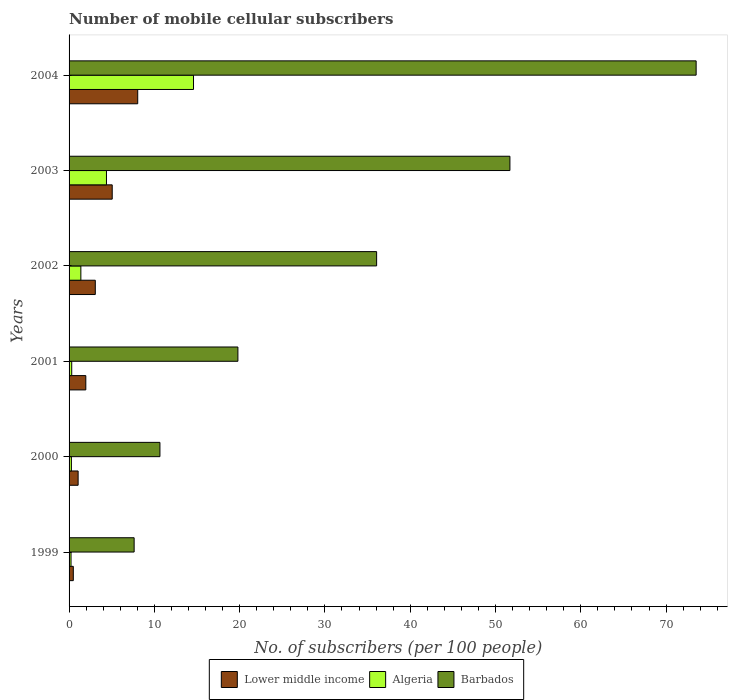How many different coloured bars are there?
Make the answer very short. 3. Are the number of bars on each tick of the Y-axis equal?
Ensure brevity in your answer.  Yes. What is the label of the 1st group of bars from the top?
Make the answer very short. 2004. In how many cases, is the number of bars for a given year not equal to the number of legend labels?
Offer a very short reply. 0. What is the number of mobile cellular subscribers in Algeria in 2000?
Make the answer very short. 0.27. Across all years, what is the maximum number of mobile cellular subscribers in Barbados?
Your answer should be very brief. 73.52. Across all years, what is the minimum number of mobile cellular subscribers in Lower middle income?
Your answer should be very brief. 0.5. In which year was the number of mobile cellular subscribers in Barbados maximum?
Provide a succinct answer. 2004. In which year was the number of mobile cellular subscribers in Lower middle income minimum?
Make the answer very short. 1999. What is the total number of mobile cellular subscribers in Barbados in the graph?
Your answer should be compact. 199.35. What is the difference between the number of mobile cellular subscribers in Barbados in 2001 and that in 2004?
Offer a very short reply. -53.73. What is the difference between the number of mobile cellular subscribers in Barbados in 2003 and the number of mobile cellular subscribers in Lower middle income in 2002?
Provide a succinct answer. 48.62. What is the average number of mobile cellular subscribers in Lower middle income per year?
Offer a very short reply. 3.28. In the year 2002, what is the difference between the number of mobile cellular subscribers in Algeria and number of mobile cellular subscribers in Barbados?
Ensure brevity in your answer.  -34.68. In how many years, is the number of mobile cellular subscribers in Lower middle income greater than 30 ?
Ensure brevity in your answer.  0. What is the ratio of the number of mobile cellular subscribers in Barbados in 2000 to that in 2001?
Your answer should be very brief. 0.54. Is the number of mobile cellular subscribers in Algeria in 2000 less than that in 2001?
Your response must be concise. Yes. What is the difference between the highest and the second highest number of mobile cellular subscribers in Lower middle income?
Your answer should be very brief. 2.99. What is the difference between the highest and the lowest number of mobile cellular subscribers in Algeria?
Keep it short and to the point. 14.36. In how many years, is the number of mobile cellular subscribers in Barbados greater than the average number of mobile cellular subscribers in Barbados taken over all years?
Your answer should be very brief. 3. What does the 2nd bar from the top in 2002 represents?
Give a very brief answer. Algeria. What does the 2nd bar from the bottom in 2000 represents?
Your answer should be compact. Algeria. Are the values on the major ticks of X-axis written in scientific E-notation?
Give a very brief answer. No. Does the graph contain any zero values?
Your response must be concise. No. How many legend labels are there?
Give a very brief answer. 3. How are the legend labels stacked?
Make the answer very short. Horizontal. What is the title of the graph?
Your response must be concise. Number of mobile cellular subscribers. Does "Faeroe Islands" appear as one of the legend labels in the graph?
Your answer should be very brief. No. What is the label or title of the X-axis?
Keep it short and to the point. No. of subscribers (per 100 people). What is the label or title of the Y-axis?
Your answer should be compact. Years. What is the No. of subscribers (per 100 people) of Lower middle income in 1999?
Ensure brevity in your answer.  0.5. What is the No. of subscribers (per 100 people) of Algeria in 1999?
Ensure brevity in your answer.  0.23. What is the No. of subscribers (per 100 people) in Barbados in 1999?
Ensure brevity in your answer.  7.63. What is the No. of subscribers (per 100 people) of Lower middle income in 2000?
Your answer should be compact. 1.06. What is the No. of subscribers (per 100 people) of Algeria in 2000?
Your answer should be very brief. 0.27. What is the No. of subscribers (per 100 people) in Barbados in 2000?
Offer a terse response. 10.65. What is the No. of subscribers (per 100 people) in Lower middle income in 2001?
Your answer should be very brief. 1.96. What is the No. of subscribers (per 100 people) of Algeria in 2001?
Your answer should be very brief. 0.31. What is the No. of subscribers (per 100 people) in Barbados in 2001?
Your response must be concise. 19.8. What is the No. of subscribers (per 100 people) in Lower middle income in 2002?
Keep it short and to the point. 3.07. What is the No. of subscribers (per 100 people) of Algeria in 2002?
Provide a short and direct response. 1.38. What is the No. of subscribers (per 100 people) of Barbados in 2002?
Your answer should be compact. 36.06. What is the No. of subscribers (per 100 people) in Lower middle income in 2003?
Ensure brevity in your answer.  5.06. What is the No. of subscribers (per 100 people) of Algeria in 2003?
Provide a succinct answer. 4.38. What is the No. of subscribers (per 100 people) of Barbados in 2003?
Offer a terse response. 51.69. What is the No. of subscribers (per 100 people) in Lower middle income in 2004?
Offer a terse response. 8.05. What is the No. of subscribers (per 100 people) in Algeria in 2004?
Offer a very short reply. 14.59. What is the No. of subscribers (per 100 people) in Barbados in 2004?
Give a very brief answer. 73.52. Across all years, what is the maximum No. of subscribers (per 100 people) of Lower middle income?
Provide a succinct answer. 8.05. Across all years, what is the maximum No. of subscribers (per 100 people) in Algeria?
Give a very brief answer. 14.59. Across all years, what is the maximum No. of subscribers (per 100 people) of Barbados?
Make the answer very short. 73.52. Across all years, what is the minimum No. of subscribers (per 100 people) in Lower middle income?
Keep it short and to the point. 0.5. Across all years, what is the minimum No. of subscribers (per 100 people) in Algeria?
Your response must be concise. 0.23. Across all years, what is the minimum No. of subscribers (per 100 people) in Barbados?
Ensure brevity in your answer.  7.63. What is the total No. of subscribers (per 100 people) of Lower middle income in the graph?
Keep it short and to the point. 19.7. What is the total No. of subscribers (per 100 people) in Algeria in the graph?
Keep it short and to the point. 21.17. What is the total No. of subscribers (per 100 people) in Barbados in the graph?
Offer a very short reply. 199.35. What is the difference between the No. of subscribers (per 100 people) in Lower middle income in 1999 and that in 2000?
Ensure brevity in your answer.  -0.56. What is the difference between the No. of subscribers (per 100 people) in Algeria in 1999 and that in 2000?
Provide a short and direct response. -0.04. What is the difference between the No. of subscribers (per 100 people) in Barbados in 1999 and that in 2000?
Your response must be concise. -3.03. What is the difference between the No. of subscribers (per 100 people) in Lower middle income in 1999 and that in 2001?
Provide a short and direct response. -1.47. What is the difference between the No. of subscribers (per 100 people) in Algeria in 1999 and that in 2001?
Offer a very short reply. -0.08. What is the difference between the No. of subscribers (per 100 people) of Barbados in 1999 and that in 2001?
Provide a short and direct response. -12.17. What is the difference between the No. of subscribers (per 100 people) in Lower middle income in 1999 and that in 2002?
Your answer should be compact. -2.58. What is the difference between the No. of subscribers (per 100 people) in Algeria in 1999 and that in 2002?
Your answer should be compact. -1.15. What is the difference between the No. of subscribers (per 100 people) of Barbados in 1999 and that in 2002?
Give a very brief answer. -28.43. What is the difference between the No. of subscribers (per 100 people) in Lower middle income in 1999 and that in 2003?
Offer a very short reply. -4.56. What is the difference between the No. of subscribers (per 100 people) in Algeria in 1999 and that in 2003?
Keep it short and to the point. -4.15. What is the difference between the No. of subscribers (per 100 people) in Barbados in 1999 and that in 2003?
Make the answer very short. -44.06. What is the difference between the No. of subscribers (per 100 people) of Lower middle income in 1999 and that in 2004?
Make the answer very short. -7.55. What is the difference between the No. of subscribers (per 100 people) in Algeria in 1999 and that in 2004?
Provide a succinct answer. -14.36. What is the difference between the No. of subscribers (per 100 people) in Barbados in 1999 and that in 2004?
Offer a very short reply. -65.9. What is the difference between the No. of subscribers (per 100 people) in Lower middle income in 2000 and that in 2001?
Your answer should be compact. -0.9. What is the difference between the No. of subscribers (per 100 people) of Algeria in 2000 and that in 2001?
Provide a succinct answer. -0.04. What is the difference between the No. of subscribers (per 100 people) in Barbados in 2000 and that in 2001?
Make the answer very short. -9.14. What is the difference between the No. of subscribers (per 100 people) in Lower middle income in 2000 and that in 2002?
Give a very brief answer. -2.01. What is the difference between the No. of subscribers (per 100 people) in Algeria in 2000 and that in 2002?
Your answer should be very brief. -1.11. What is the difference between the No. of subscribers (per 100 people) of Barbados in 2000 and that in 2002?
Give a very brief answer. -25.41. What is the difference between the No. of subscribers (per 100 people) in Lower middle income in 2000 and that in 2003?
Make the answer very short. -4. What is the difference between the No. of subscribers (per 100 people) in Algeria in 2000 and that in 2003?
Your response must be concise. -4.11. What is the difference between the No. of subscribers (per 100 people) of Barbados in 2000 and that in 2003?
Keep it short and to the point. -41.04. What is the difference between the No. of subscribers (per 100 people) of Lower middle income in 2000 and that in 2004?
Offer a terse response. -6.99. What is the difference between the No. of subscribers (per 100 people) in Algeria in 2000 and that in 2004?
Your response must be concise. -14.32. What is the difference between the No. of subscribers (per 100 people) in Barbados in 2000 and that in 2004?
Offer a very short reply. -62.87. What is the difference between the No. of subscribers (per 100 people) of Lower middle income in 2001 and that in 2002?
Provide a short and direct response. -1.11. What is the difference between the No. of subscribers (per 100 people) in Algeria in 2001 and that in 2002?
Give a very brief answer. -1.07. What is the difference between the No. of subscribers (per 100 people) in Barbados in 2001 and that in 2002?
Keep it short and to the point. -16.27. What is the difference between the No. of subscribers (per 100 people) of Lower middle income in 2001 and that in 2003?
Provide a succinct answer. -3.1. What is the difference between the No. of subscribers (per 100 people) of Algeria in 2001 and that in 2003?
Your response must be concise. -4.07. What is the difference between the No. of subscribers (per 100 people) in Barbados in 2001 and that in 2003?
Give a very brief answer. -31.89. What is the difference between the No. of subscribers (per 100 people) of Lower middle income in 2001 and that in 2004?
Give a very brief answer. -6.09. What is the difference between the No. of subscribers (per 100 people) of Algeria in 2001 and that in 2004?
Ensure brevity in your answer.  -14.28. What is the difference between the No. of subscribers (per 100 people) in Barbados in 2001 and that in 2004?
Your answer should be very brief. -53.73. What is the difference between the No. of subscribers (per 100 people) of Lower middle income in 2002 and that in 2003?
Provide a short and direct response. -1.98. What is the difference between the No. of subscribers (per 100 people) of Algeria in 2002 and that in 2003?
Provide a succinct answer. -3. What is the difference between the No. of subscribers (per 100 people) in Barbados in 2002 and that in 2003?
Your answer should be very brief. -15.63. What is the difference between the No. of subscribers (per 100 people) in Lower middle income in 2002 and that in 2004?
Offer a terse response. -4.97. What is the difference between the No. of subscribers (per 100 people) in Algeria in 2002 and that in 2004?
Make the answer very short. -13.21. What is the difference between the No. of subscribers (per 100 people) in Barbados in 2002 and that in 2004?
Your answer should be very brief. -37.46. What is the difference between the No. of subscribers (per 100 people) of Lower middle income in 2003 and that in 2004?
Your answer should be very brief. -2.99. What is the difference between the No. of subscribers (per 100 people) of Algeria in 2003 and that in 2004?
Offer a terse response. -10.21. What is the difference between the No. of subscribers (per 100 people) in Barbados in 2003 and that in 2004?
Your answer should be very brief. -21.83. What is the difference between the No. of subscribers (per 100 people) of Lower middle income in 1999 and the No. of subscribers (per 100 people) of Algeria in 2000?
Provide a succinct answer. 0.23. What is the difference between the No. of subscribers (per 100 people) of Lower middle income in 1999 and the No. of subscribers (per 100 people) of Barbados in 2000?
Ensure brevity in your answer.  -10.16. What is the difference between the No. of subscribers (per 100 people) in Algeria in 1999 and the No. of subscribers (per 100 people) in Barbados in 2000?
Your answer should be very brief. -10.42. What is the difference between the No. of subscribers (per 100 people) in Lower middle income in 1999 and the No. of subscribers (per 100 people) in Algeria in 2001?
Give a very brief answer. 0.19. What is the difference between the No. of subscribers (per 100 people) in Lower middle income in 1999 and the No. of subscribers (per 100 people) in Barbados in 2001?
Your answer should be compact. -19.3. What is the difference between the No. of subscribers (per 100 people) of Algeria in 1999 and the No. of subscribers (per 100 people) of Barbados in 2001?
Your answer should be very brief. -19.57. What is the difference between the No. of subscribers (per 100 people) of Lower middle income in 1999 and the No. of subscribers (per 100 people) of Algeria in 2002?
Ensure brevity in your answer.  -0.89. What is the difference between the No. of subscribers (per 100 people) in Lower middle income in 1999 and the No. of subscribers (per 100 people) in Barbados in 2002?
Give a very brief answer. -35.56. What is the difference between the No. of subscribers (per 100 people) of Algeria in 1999 and the No. of subscribers (per 100 people) of Barbados in 2002?
Keep it short and to the point. -35.83. What is the difference between the No. of subscribers (per 100 people) in Lower middle income in 1999 and the No. of subscribers (per 100 people) in Algeria in 2003?
Offer a very short reply. -3.89. What is the difference between the No. of subscribers (per 100 people) of Lower middle income in 1999 and the No. of subscribers (per 100 people) of Barbados in 2003?
Ensure brevity in your answer.  -51.19. What is the difference between the No. of subscribers (per 100 people) of Algeria in 1999 and the No. of subscribers (per 100 people) of Barbados in 2003?
Ensure brevity in your answer.  -51.46. What is the difference between the No. of subscribers (per 100 people) in Lower middle income in 1999 and the No. of subscribers (per 100 people) in Algeria in 2004?
Your answer should be compact. -14.09. What is the difference between the No. of subscribers (per 100 people) in Lower middle income in 1999 and the No. of subscribers (per 100 people) in Barbados in 2004?
Keep it short and to the point. -73.03. What is the difference between the No. of subscribers (per 100 people) in Algeria in 1999 and the No. of subscribers (per 100 people) in Barbados in 2004?
Your answer should be compact. -73.29. What is the difference between the No. of subscribers (per 100 people) of Lower middle income in 2000 and the No. of subscribers (per 100 people) of Algeria in 2001?
Your response must be concise. 0.75. What is the difference between the No. of subscribers (per 100 people) in Lower middle income in 2000 and the No. of subscribers (per 100 people) in Barbados in 2001?
Keep it short and to the point. -18.73. What is the difference between the No. of subscribers (per 100 people) of Algeria in 2000 and the No. of subscribers (per 100 people) of Barbados in 2001?
Give a very brief answer. -19.52. What is the difference between the No. of subscribers (per 100 people) in Lower middle income in 2000 and the No. of subscribers (per 100 people) in Algeria in 2002?
Offer a terse response. -0.32. What is the difference between the No. of subscribers (per 100 people) of Lower middle income in 2000 and the No. of subscribers (per 100 people) of Barbados in 2002?
Give a very brief answer. -35. What is the difference between the No. of subscribers (per 100 people) in Algeria in 2000 and the No. of subscribers (per 100 people) in Barbados in 2002?
Make the answer very short. -35.79. What is the difference between the No. of subscribers (per 100 people) in Lower middle income in 2000 and the No. of subscribers (per 100 people) in Algeria in 2003?
Your answer should be compact. -3.32. What is the difference between the No. of subscribers (per 100 people) of Lower middle income in 2000 and the No. of subscribers (per 100 people) of Barbados in 2003?
Ensure brevity in your answer.  -50.63. What is the difference between the No. of subscribers (per 100 people) in Algeria in 2000 and the No. of subscribers (per 100 people) in Barbados in 2003?
Provide a short and direct response. -51.42. What is the difference between the No. of subscribers (per 100 people) in Lower middle income in 2000 and the No. of subscribers (per 100 people) in Algeria in 2004?
Give a very brief answer. -13.53. What is the difference between the No. of subscribers (per 100 people) in Lower middle income in 2000 and the No. of subscribers (per 100 people) in Barbados in 2004?
Give a very brief answer. -72.46. What is the difference between the No. of subscribers (per 100 people) of Algeria in 2000 and the No. of subscribers (per 100 people) of Barbados in 2004?
Make the answer very short. -73.25. What is the difference between the No. of subscribers (per 100 people) in Lower middle income in 2001 and the No. of subscribers (per 100 people) in Algeria in 2002?
Your answer should be very brief. 0.58. What is the difference between the No. of subscribers (per 100 people) in Lower middle income in 2001 and the No. of subscribers (per 100 people) in Barbados in 2002?
Provide a succinct answer. -34.1. What is the difference between the No. of subscribers (per 100 people) of Algeria in 2001 and the No. of subscribers (per 100 people) of Barbados in 2002?
Give a very brief answer. -35.75. What is the difference between the No. of subscribers (per 100 people) of Lower middle income in 2001 and the No. of subscribers (per 100 people) of Algeria in 2003?
Keep it short and to the point. -2.42. What is the difference between the No. of subscribers (per 100 people) of Lower middle income in 2001 and the No. of subscribers (per 100 people) of Barbados in 2003?
Make the answer very short. -49.73. What is the difference between the No. of subscribers (per 100 people) in Algeria in 2001 and the No. of subscribers (per 100 people) in Barbados in 2003?
Ensure brevity in your answer.  -51.38. What is the difference between the No. of subscribers (per 100 people) in Lower middle income in 2001 and the No. of subscribers (per 100 people) in Algeria in 2004?
Provide a short and direct response. -12.63. What is the difference between the No. of subscribers (per 100 people) of Lower middle income in 2001 and the No. of subscribers (per 100 people) of Barbados in 2004?
Make the answer very short. -71.56. What is the difference between the No. of subscribers (per 100 people) of Algeria in 2001 and the No. of subscribers (per 100 people) of Barbados in 2004?
Your answer should be compact. -73.21. What is the difference between the No. of subscribers (per 100 people) of Lower middle income in 2002 and the No. of subscribers (per 100 people) of Algeria in 2003?
Provide a short and direct response. -1.31. What is the difference between the No. of subscribers (per 100 people) in Lower middle income in 2002 and the No. of subscribers (per 100 people) in Barbados in 2003?
Make the answer very short. -48.62. What is the difference between the No. of subscribers (per 100 people) in Algeria in 2002 and the No. of subscribers (per 100 people) in Barbados in 2003?
Your answer should be very brief. -50.31. What is the difference between the No. of subscribers (per 100 people) of Lower middle income in 2002 and the No. of subscribers (per 100 people) of Algeria in 2004?
Your answer should be very brief. -11.52. What is the difference between the No. of subscribers (per 100 people) of Lower middle income in 2002 and the No. of subscribers (per 100 people) of Barbados in 2004?
Make the answer very short. -70.45. What is the difference between the No. of subscribers (per 100 people) in Algeria in 2002 and the No. of subscribers (per 100 people) in Barbados in 2004?
Offer a terse response. -72.14. What is the difference between the No. of subscribers (per 100 people) of Lower middle income in 2003 and the No. of subscribers (per 100 people) of Algeria in 2004?
Make the answer very short. -9.53. What is the difference between the No. of subscribers (per 100 people) in Lower middle income in 2003 and the No. of subscribers (per 100 people) in Barbados in 2004?
Provide a short and direct response. -68.47. What is the difference between the No. of subscribers (per 100 people) of Algeria in 2003 and the No. of subscribers (per 100 people) of Barbados in 2004?
Offer a very short reply. -69.14. What is the average No. of subscribers (per 100 people) of Lower middle income per year?
Give a very brief answer. 3.28. What is the average No. of subscribers (per 100 people) of Algeria per year?
Provide a succinct answer. 3.53. What is the average No. of subscribers (per 100 people) in Barbados per year?
Provide a short and direct response. 33.23. In the year 1999, what is the difference between the No. of subscribers (per 100 people) in Lower middle income and No. of subscribers (per 100 people) in Algeria?
Provide a succinct answer. 0.27. In the year 1999, what is the difference between the No. of subscribers (per 100 people) in Lower middle income and No. of subscribers (per 100 people) in Barbados?
Your answer should be compact. -7.13. In the year 1999, what is the difference between the No. of subscribers (per 100 people) in Algeria and No. of subscribers (per 100 people) in Barbados?
Your answer should be compact. -7.4. In the year 2000, what is the difference between the No. of subscribers (per 100 people) in Lower middle income and No. of subscribers (per 100 people) in Algeria?
Your answer should be very brief. 0.79. In the year 2000, what is the difference between the No. of subscribers (per 100 people) in Lower middle income and No. of subscribers (per 100 people) in Barbados?
Offer a very short reply. -9.59. In the year 2000, what is the difference between the No. of subscribers (per 100 people) in Algeria and No. of subscribers (per 100 people) in Barbados?
Offer a very short reply. -10.38. In the year 2001, what is the difference between the No. of subscribers (per 100 people) in Lower middle income and No. of subscribers (per 100 people) in Algeria?
Your response must be concise. 1.65. In the year 2001, what is the difference between the No. of subscribers (per 100 people) of Lower middle income and No. of subscribers (per 100 people) of Barbados?
Keep it short and to the point. -17.83. In the year 2001, what is the difference between the No. of subscribers (per 100 people) in Algeria and No. of subscribers (per 100 people) in Barbados?
Provide a short and direct response. -19.48. In the year 2002, what is the difference between the No. of subscribers (per 100 people) of Lower middle income and No. of subscribers (per 100 people) of Algeria?
Give a very brief answer. 1.69. In the year 2002, what is the difference between the No. of subscribers (per 100 people) in Lower middle income and No. of subscribers (per 100 people) in Barbados?
Provide a succinct answer. -32.99. In the year 2002, what is the difference between the No. of subscribers (per 100 people) in Algeria and No. of subscribers (per 100 people) in Barbados?
Offer a very short reply. -34.68. In the year 2003, what is the difference between the No. of subscribers (per 100 people) of Lower middle income and No. of subscribers (per 100 people) of Algeria?
Keep it short and to the point. 0.67. In the year 2003, what is the difference between the No. of subscribers (per 100 people) of Lower middle income and No. of subscribers (per 100 people) of Barbados?
Your response must be concise. -46.63. In the year 2003, what is the difference between the No. of subscribers (per 100 people) in Algeria and No. of subscribers (per 100 people) in Barbados?
Ensure brevity in your answer.  -47.31. In the year 2004, what is the difference between the No. of subscribers (per 100 people) in Lower middle income and No. of subscribers (per 100 people) in Algeria?
Your answer should be very brief. -6.54. In the year 2004, what is the difference between the No. of subscribers (per 100 people) in Lower middle income and No. of subscribers (per 100 people) in Barbados?
Your response must be concise. -65.48. In the year 2004, what is the difference between the No. of subscribers (per 100 people) in Algeria and No. of subscribers (per 100 people) in Barbados?
Give a very brief answer. -58.93. What is the ratio of the No. of subscribers (per 100 people) of Lower middle income in 1999 to that in 2000?
Your answer should be very brief. 0.47. What is the ratio of the No. of subscribers (per 100 people) of Algeria in 1999 to that in 2000?
Provide a short and direct response. 0.85. What is the ratio of the No. of subscribers (per 100 people) of Barbados in 1999 to that in 2000?
Give a very brief answer. 0.72. What is the ratio of the No. of subscribers (per 100 people) in Lower middle income in 1999 to that in 2001?
Give a very brief answer. 0.25. What is the ratio of the No. of subscribers (per 100 people) of Algeria in 1999 to that in 2001?
Provide a short and direct response. 0.74. What is the ratio of the No. of subscribers (per 100 people) in Barbados in 1999 to that in 2001?
Your answer should be very brief. 0.39. What is the ratio of the No. of subscribers (per 100 people) of Lower middle income in 1999 to that in 2002?
Keep it short and to the point. 0.16. What is the ratio of the No. of subscribers (per 100 people) of Algeria in 1999 to that in 2002?
Make the answer very short. 0.17. What is the ratio of the No. of subscribers (per 100 people) of Barbados in 1999 to that in 2002?
Your response must be concise. 0.21. What is the ratio of the No. of subscribers (per 100 people) of Lower middle income in 1999 to that in 2003?
Make the answer very short. 0.1. What is the ratio of the No. of subscribers (per 100 people) of Algeria in 1999 to that in 2003?
Offer a very short reply. 0.05. What is the ratio of the No. of subscribers (per 100 people) in Barbados in 1999 to that in 2003?
Make the answer very short. 0.15. What is the ratio of the No. of subscribers (per 100 people) in Lower middle income in 1999 to that in 2004?
Make the answer very short. 0.06. What is the ratio of the No. of subscribers (per 100 people) in Algeria in 1999 to that in 2004?
Keep it short and to the point. 0.02. What is the ratio of the No. of subscribers (per 100 people) in Barbados in 1999 to that in 2004?
Give a very brief answer. 0.1. What is the ratio of the No. of subscribers (per 100 people) in Lower middle income in 2000 to that in 2001?
Offer a terse response. 0.54. What is the ratio of the No. of subscribers (per 100 people) of Algeria in 2000 to that in 2001?
Make the answer very short. 0.87. What is the ratio of the No. of subscribers (per 100 people) of Barbados in 2000 to that in 2001?
Provide a succinct answer. 0.54. What is the ratio of the No. of subscribers (per 100 people) of Lower middle income in 2000 to that in 2002?
Offer a terse response. 0.34. What is the ratio of the No. of subscribers (per 100 people) of Algeria in 2000 to that in 2002?
Offer a very short reply. 0.2. What is the ratio of the No. of subscribers (per 100 people) in Barbados in 2000 to that in 2002?
Your answer should be very brief. 0.3. What is the ratio of the No. of subscribers (per 100 people) of Lower middle income in 2000 to that in 2003?
Ensure brevity in your answer.  0.21. What is the ratio of the No. of subscribers (per 100 people) of Algeria in 2000 to that in 2003?
Ensure brevity in your answer.  0.06. What is the ratio of the No. of subscribers (per 100 people) of Barbados in 2000 to that in 2003?
Offer a terse response. 0.21. What is the ratio of the No. of subscribers (per 100 people) in Lower middle income in 2000 to that in 2004?
Give a very brief answer. 0.13. What is the ratio of the No. of subscribers (per 100 people) of Algeria in 2000 to that in 2004?
Your answer should be compact. 0.02. What is the ratio of the No. of subscribers (per 100 people) in Barbados in 2000 to that in 2004?
Offer a very short reply. 0.14. What is the ratio of the No. of subscribers (per 100 people) in Lower middle income in 2001 to that in 2002?
Keep it short and to the point. 0.64. What is the ratio of the No. of subscribers (per 100 people) in Algeria in 2001 to that in 2002?
Offer a very short reply. 0.23. What is the ratio of the No. of subscribers (per 100 people) in Barbados in 2001 to that in 2002?
Provide a succinct answer. 0.55. What is the ratio of the No. of subscribers (per 100 people) in Lower middle income in 2001 to that in 2003?
Offer a terse response. 0.39. What is the ratio of the No. of subscribers (per 100 people) in Algeria in 2001 to that in 2003?
Your answer should be compact. 0.07. What is the ratio of the No. of subscribers (per 100 people) in Barbados in 2001 to that in 2003?
Give a very brief answer. 0.38. What is the ratio of the No. of subscribers (per 100 people) in Lower middle income in 2001 to that in 2004?
Offer a terse response. 0.24. What is the ratio of the No. of subscribers (per 100 people) in Algeria in 2001 to that in 2004?
Your response must be concise. 0.02. What is the ratio of the No. of subscribers (per 100 people) of Barbados in 2001 to that in 2004?
Offer a terse response. 0.27. What is the ratio of the No. of subscribers (per 100 people) of Lower middle income in 2002 to that in 2003?
Keep it short and to the point. 0.61. What is the ratio of the No. of subscribers (per 100 people) of Algeria in 2002 to that in 2003?
Give a very brief answer. 0.32. What is the ratio of the No. of subscribers (per 100 people) of Barbados in 2002 to that in 2003?
Your answer should be compact. 0.7. What is the ratio of the No. of subscribers (per 100 people) in Lower middle income in 2002 to that in 2004?
Provide a succinct answer. 0.38. What is the ratio of the No. of subscribers (per 100 people) in Algeria in 2002 to that in 2004?
Offer a terse response. 0.09. What is the ratio of the No. of subscribers (per 100 people) of Barbados in 2002 to that in 2004?
Offer a very short reply. 0.49. What is the ratio of the No. of subscribers (per 100 people) in Lower middle income in 2003 to that in 2004?
Keep it short and to the point. 0.63. What is the ratio of the No. of subscribers (per 100 people) in Algeria in 2003 to that in 2004?
Offer a terse response. 0.3. What is the ratio of the No. of subscribers (per 100 people) of Barbados in 2003 to that in 2004?
Provide a short and direct response. 0.7. What is the difference between the highest and the second highest No. of subscribers (per 100 people) of Lower middle income?
Your answer should be compact. 2.99. What is the difference between the highest and the second highest No. of subscribers (per 100 people) of Algeria?
Offer a terse response. 10.21. What is the difference between the highest and the second highest No. of subscribers (per 100 people) of Barbados?
Give a very brief answer. 21.83. What is the difference between the highest and the lowest No. of subscribers (per 100 people) in Lower middle income?
Keep it short and to the point. 7.55. What is the difference between the highest and the lowest No. of subscribers (per 100 people) in Algeria?
Ensure brevity in your answer.  14.36. What is the difference between the highest and the lowest No. of subscribers (per 100 people) in Barbados?
Provide a short and direct response. 65.9. 